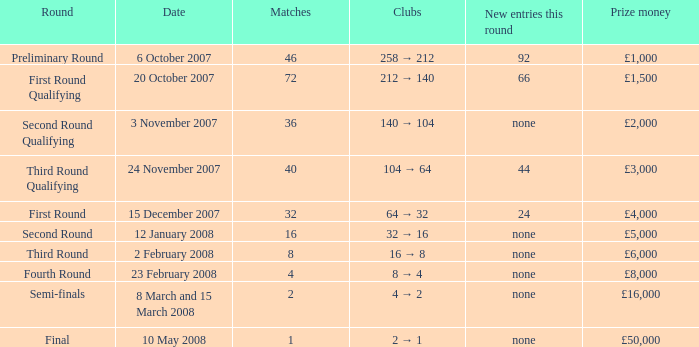What is the typical outcome for competitions with a cash prize of £3,000? 40.0. 